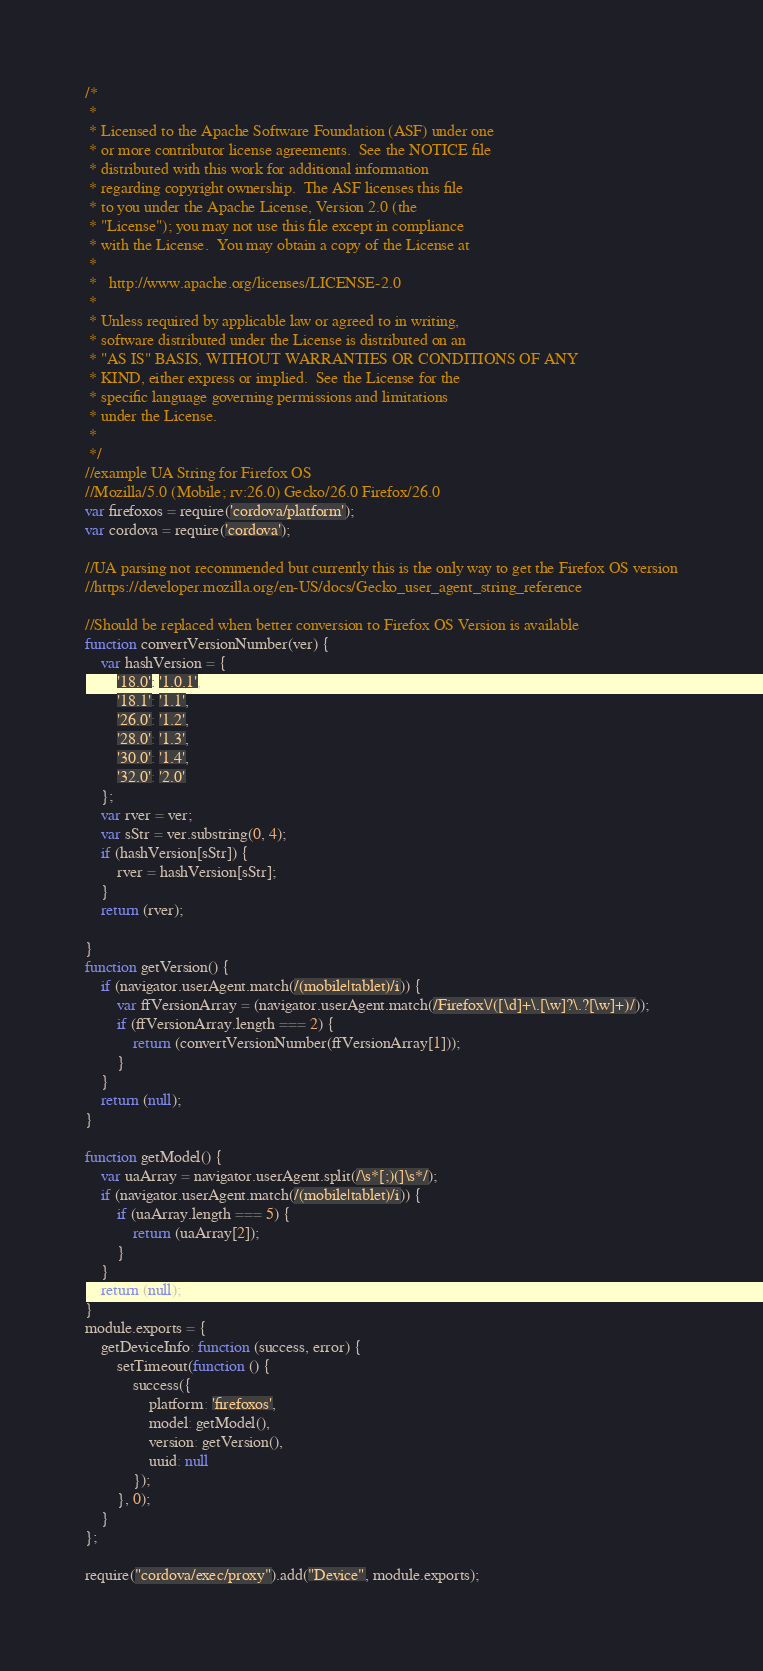Convert code to text. <code><loc_0><loc_0><loc_500><loc_500><_JavaScript_>/*
 *
 * Licensed to the Apache Software Foundation (ASF) under one
 * or more contributor license agreements.  See the NOTICE file
 * distributed with this work for additional information
 * regarding copyright ownership.  The ASF licenses this file
 * to you under the Apache License, Version 2.0 (the
 * "License"); you may not use this file except in compliance
 * with the License.  You may obtain a copy of the License at
 *
 *   http://www.apache.org/licenses/LICENSE-2.0
 *
 * Unless required by applicable law or agreed to in writing,
 * software distributed under the License is distributed on an
 * "AS IS" BASIS, WITHOUT WARRANTIES OR CONDITIONS OF ANY
 * KIND, either express or implied.  See the License for the
 * specific language governing permissions and limitations
 * under the License.
 *
 */
//example UA String for Firefox OS 
//Mozilla/5.0 (Mobile; rv:26.0) Gecko/26.0 Firefox/26.0
var firefoxos = require('cordova/platform');
var cordova = require('cordova');

//UA parsing not recommended but currently this is the only way to get the Firefox OS version
//https://developer.mozilla.org/en-US/docs/Gecko_user_agent_string_reference

//Should be replaced when better conversion to Firefox OS Version is available
function convertVersionNumber(ver) {
    var hashVersion = {
        '18.0': '1.0.1',
        '18.1': '1.1',
        '26.0': '1.2',
        '28.0': '1.3',
        '30.0': '1.4',
        '32.0': '2.0'
    };
    var rver = ver;
    var sStr = ver.substring(0, 4);
    if (hashVersion[sStr]) {
        rver = hashVersion[sStr];
    }
    return (rver);

}
function getVersion() {
    if (navigator.userAgent.match(/(mobile|tablet)/i)) {
        var ffVersionArray = (navigator.userAgent.match(/Firefox\/([\d]+\.[\w]?\.?[\w]+)/));
        if (ffVersionArray.length === 2) {
            return (convertVersionNumber(ffVersionArray[1]));
        }
    }
    return (null);
}

function getModel() {
    var uaArray = navigator.userAgent.split(/\s*[;)(]\s*/);
    if (navigator.userAgent.match(/(mobile|tablet)/i)) {
        if (uaArray.length === 5) {
            return (uaArray[2]);
        }
    }
    return (null);
}
module.exports = {
    getDeviceInfo: function (success, error) {
        setTimeout(function () {
            success({
                platform: 'firefoxos',
                model: getModel(),
                version: getVersion(),
                uuid: null
            });
        }, 0);
    }
};

require("cordova/exec/proxy").add("Device", module.exports);
</code> 